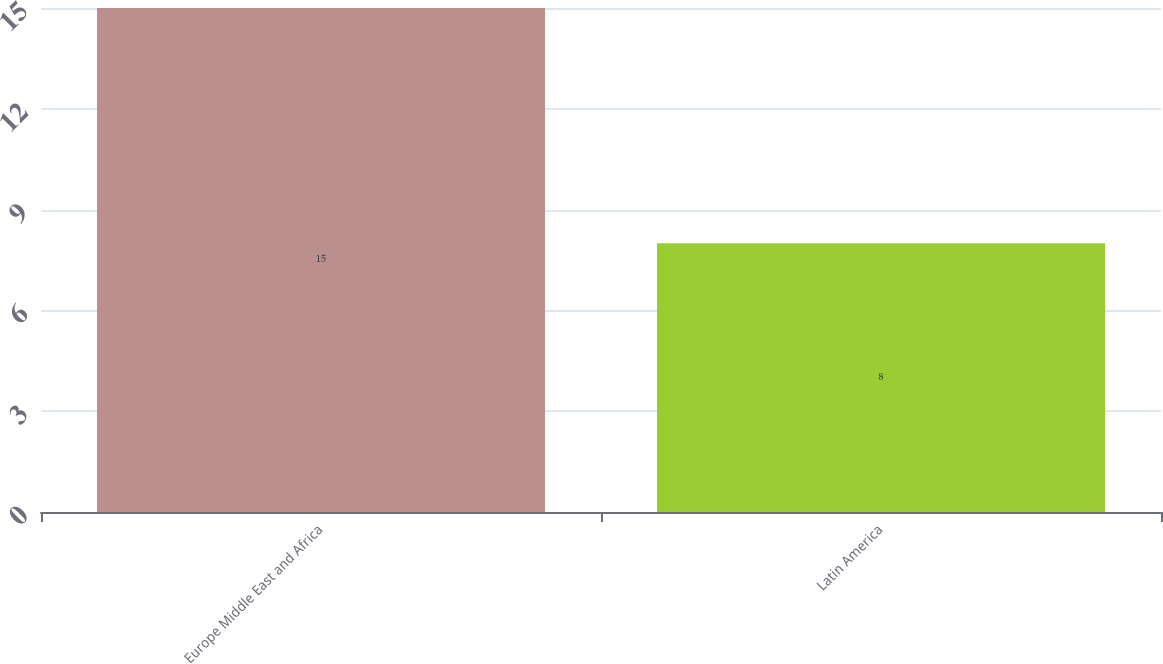Convert chart. <chart><loc_0><loc_0><loc_500><loc_500><bar_chart><fcel>Europe Middle East and Africa<fcel>Latin America<nl><fcel>15<fcel>8<nl></chart> 